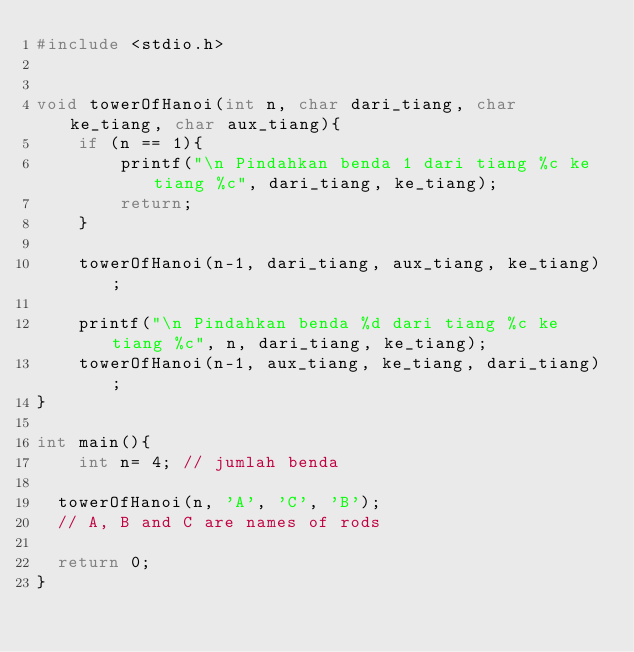<code> <loc_0><loc_0><loc_500><loc_500><_C++_>#include <stdio.h> 
  

void towerOfHanoi(int n, char dari_tiang, char ke_tiang, char aux_tiang){ 
    if (n == 1){ 
        printf("\n Pindahkan benda 1 dari tiang %c ke tiang %c", dari_tiang, ke_tiang); 
        return; 
    } 
    
    towerOfHanoi(n-1, dari_tiang, aux_tiang, ke_tiang); 
    
    printf("\n Pindahkan benda %d dari tiang %c ke tiang %c", n, dari_tiang, ke_tiang); 
    towerOfHanoi(n-1, aux_tiang, ke_tiang, dari_tiang); 
}
  
int main(){ 
    int n= 4; // jumlah benda
    
  towerOfHanoi(n, 'A', 'C', 'B');  
	// A, B and C are names of rods
    
	return 0; 
}
</code> 